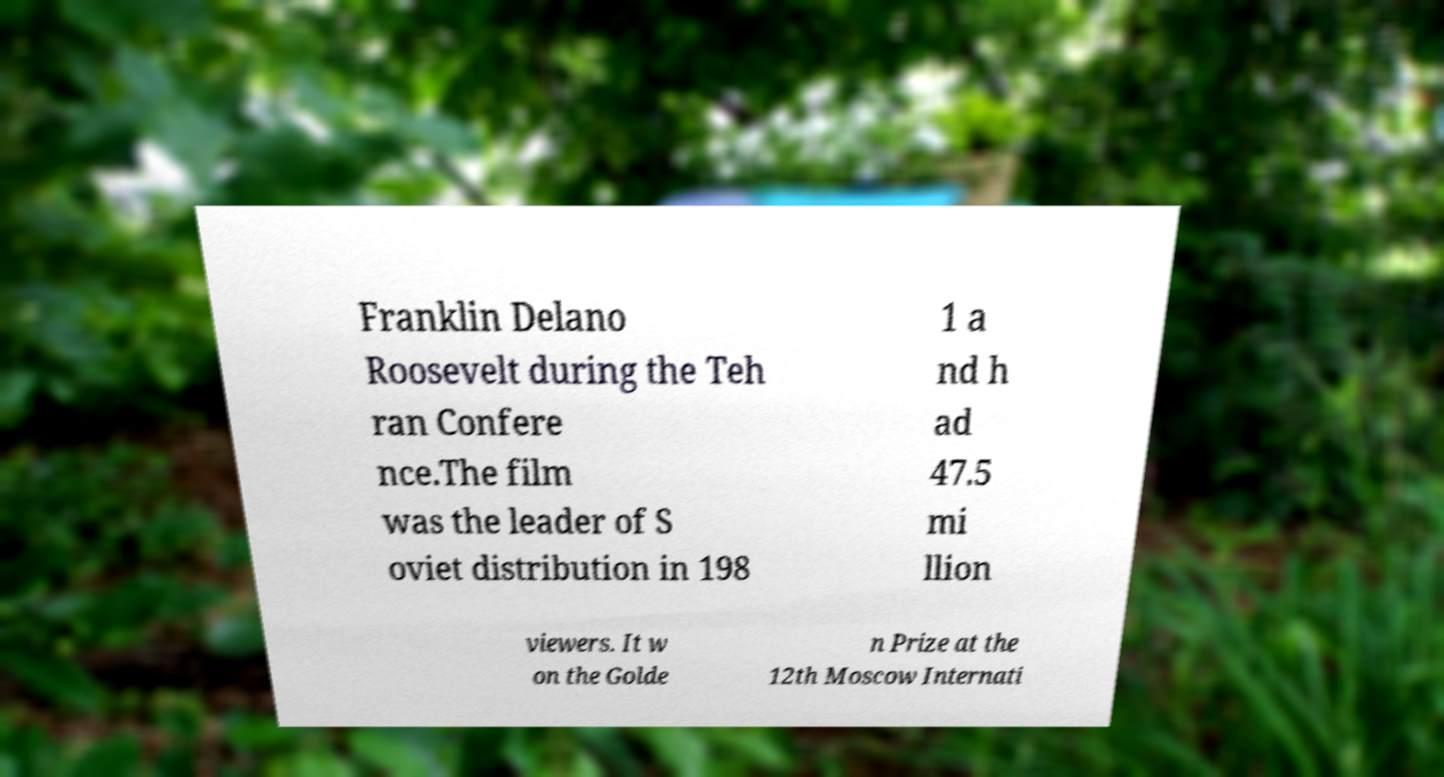There's text embedded in this image that I need extracted. Can you transcribe it verbatim? Franklin Delano Roosevelt during the Teh ran Confere nce.The film was the leader of S oviet distribution in 198 1 a nd h ad 47.5 mi llion viewers. It w on the Golde n Prize at the 12th Moscow Internati 